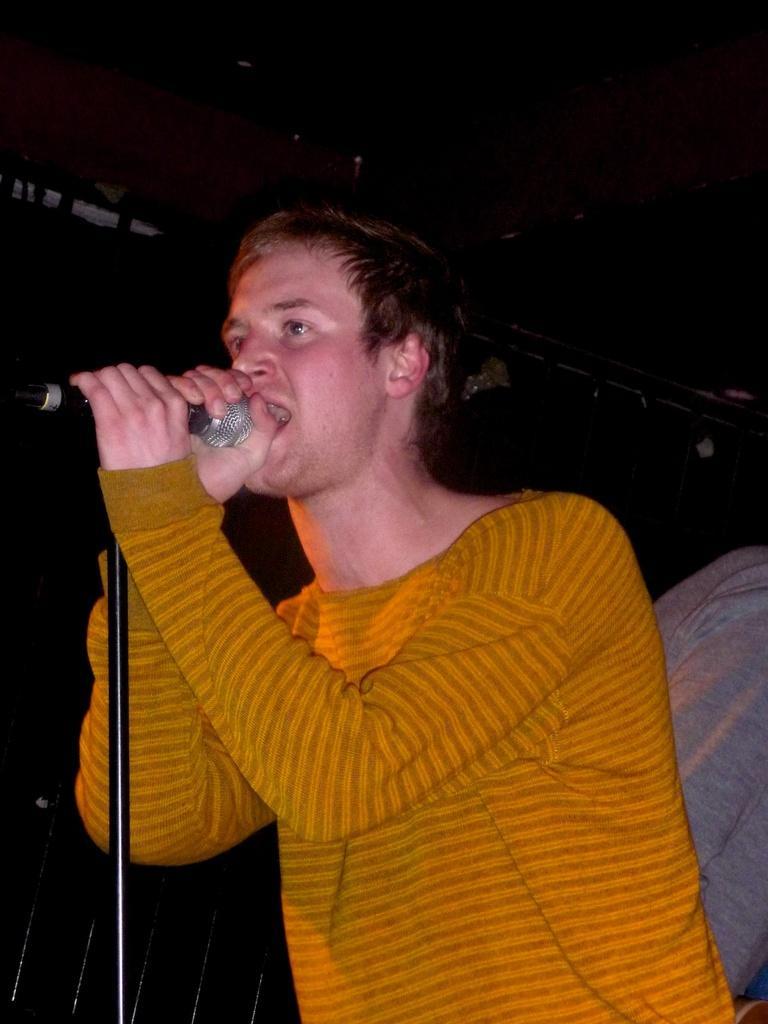Can you describe this image briefly? There is a person holding a mic with mic stand and singing. In the background it is dark. 